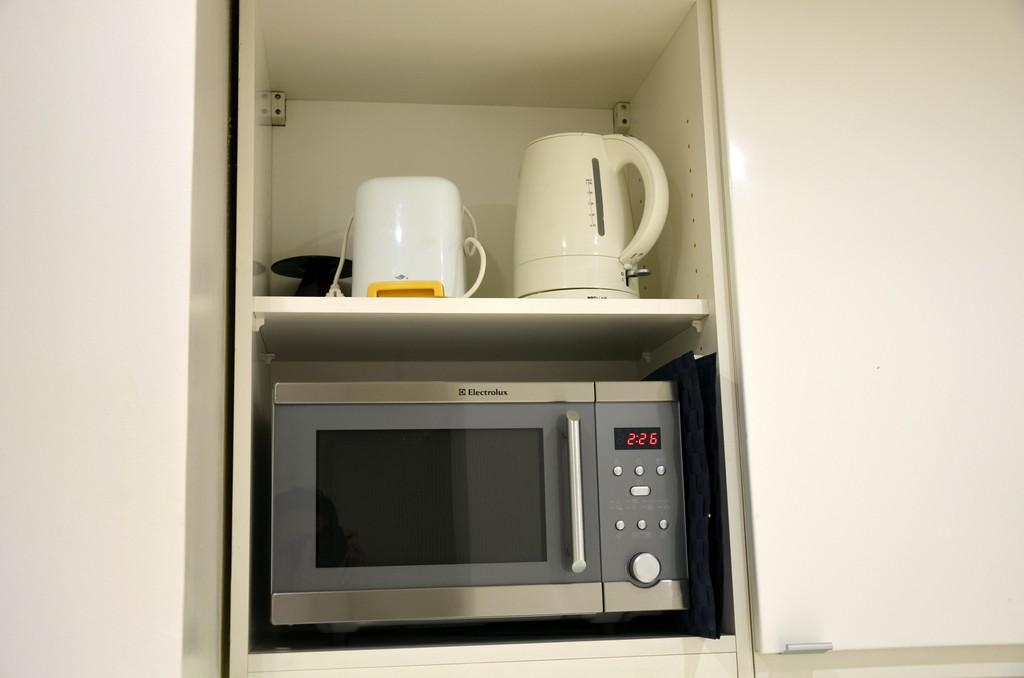<image>
Offer a succinct explanation of the picture presented. A small microwave that shows 2:26 on it with some dishes above it. 